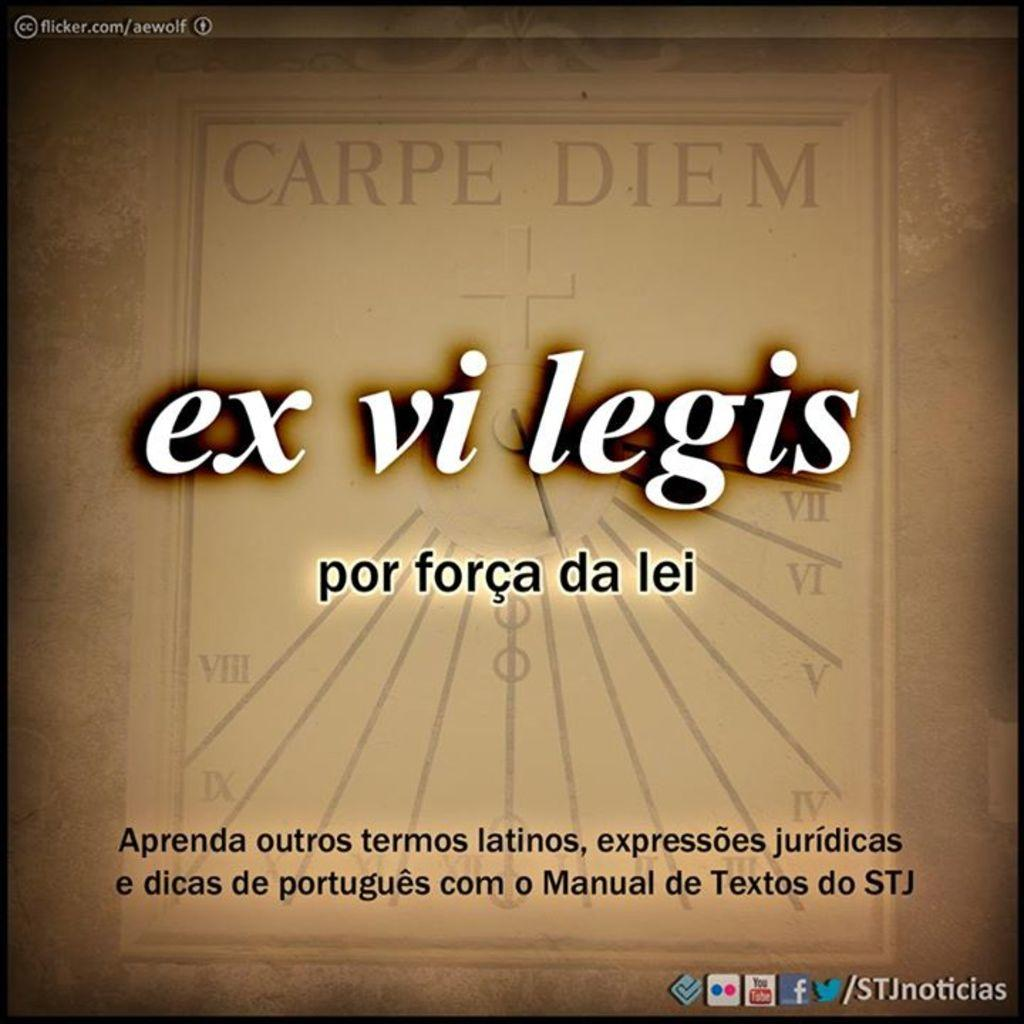Provide a one-sentence caption for the provided image. a sign reads Ex Vi Legis and Carpe Diem. 